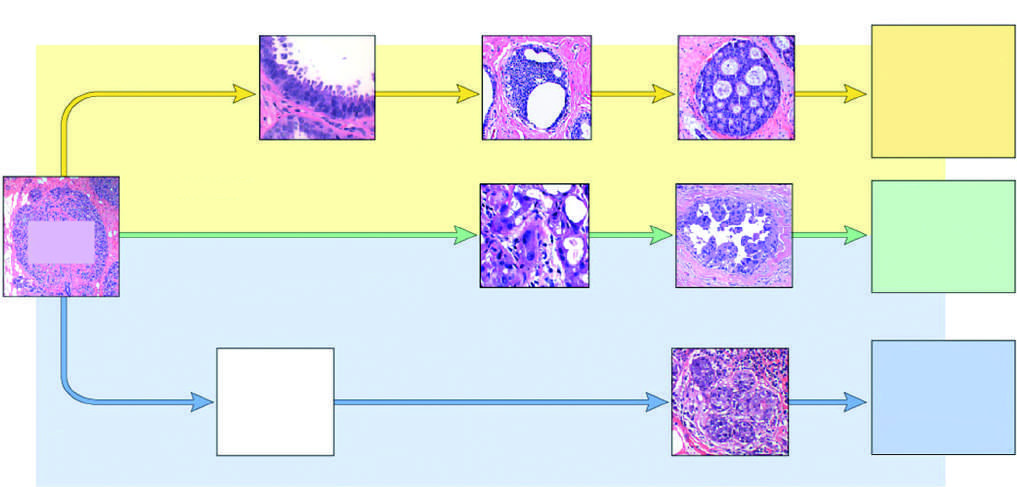do morphologically recognized precursor lesions include flat epithelial atypia, adh, and dcis?
Answer the question using a single word or phrase. Yes 